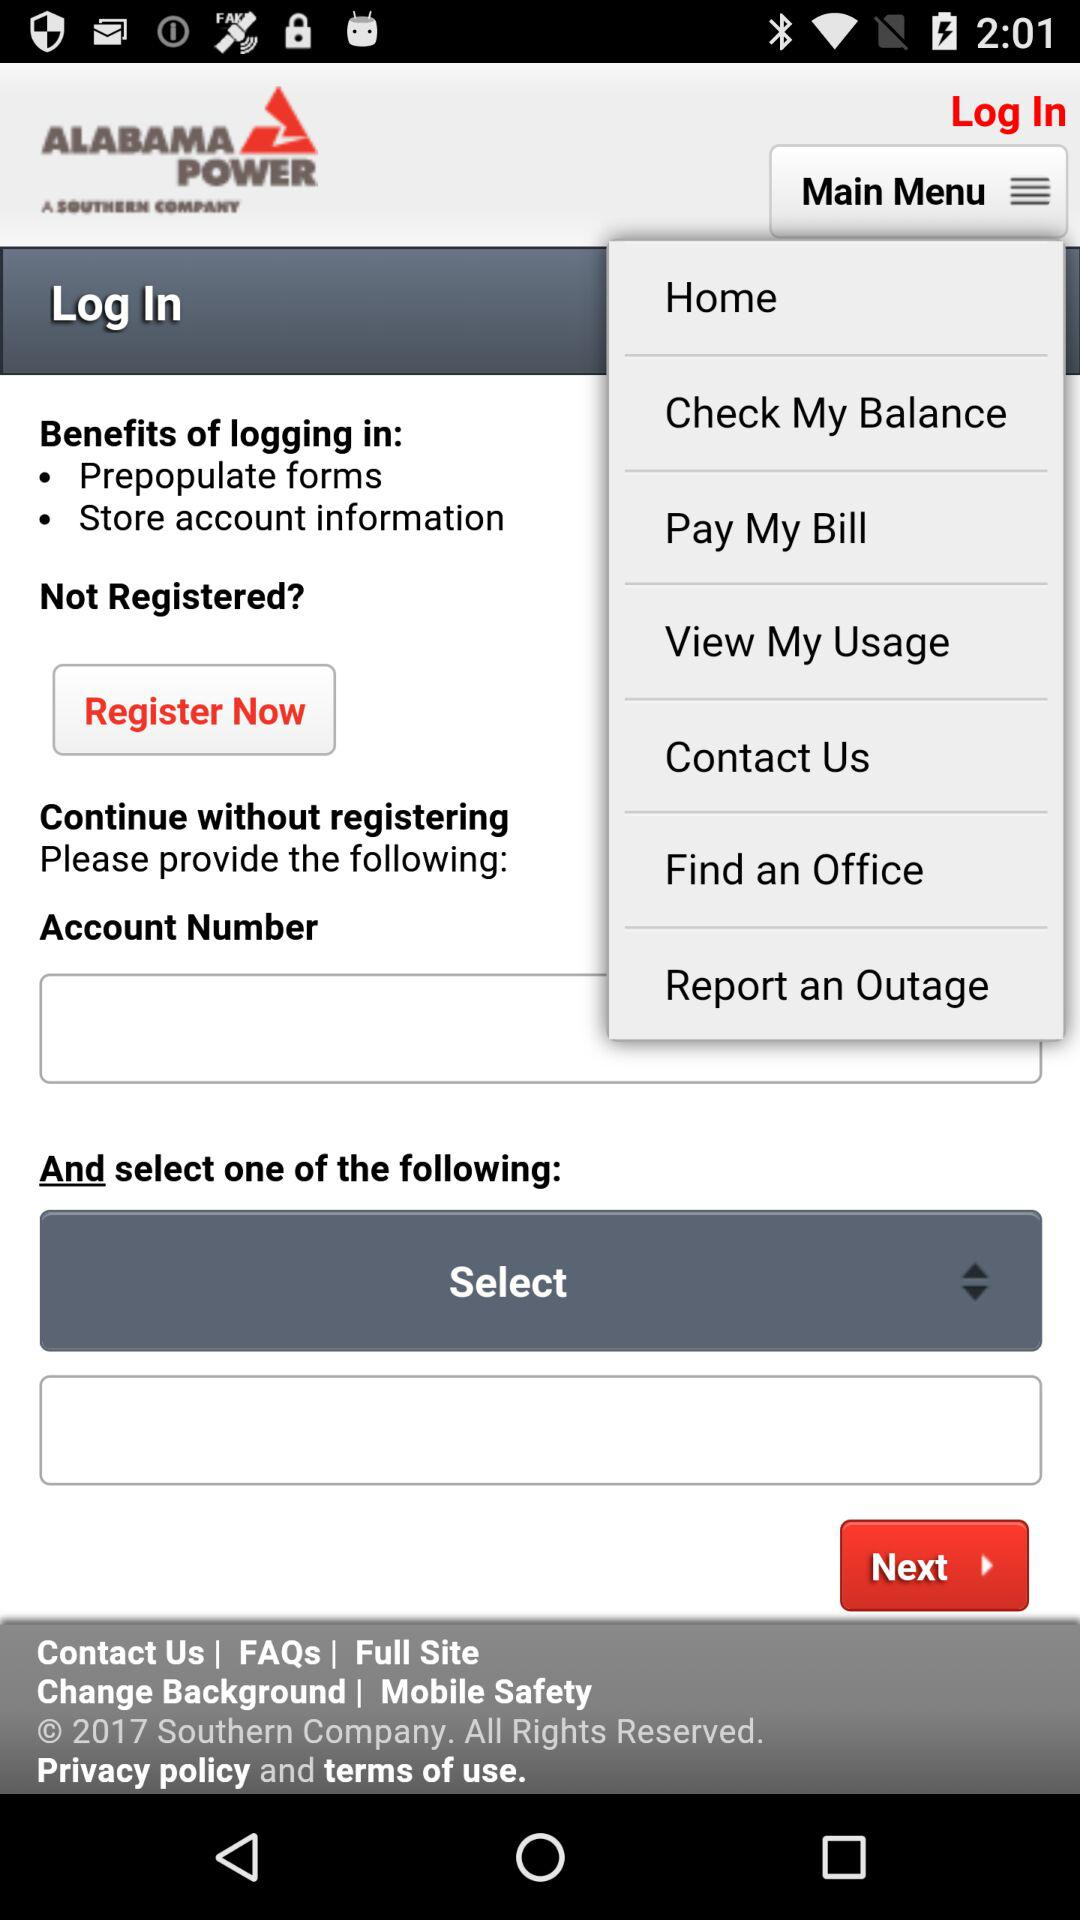What is the name of the application? The name of the application is "ALABAMA POWER". 